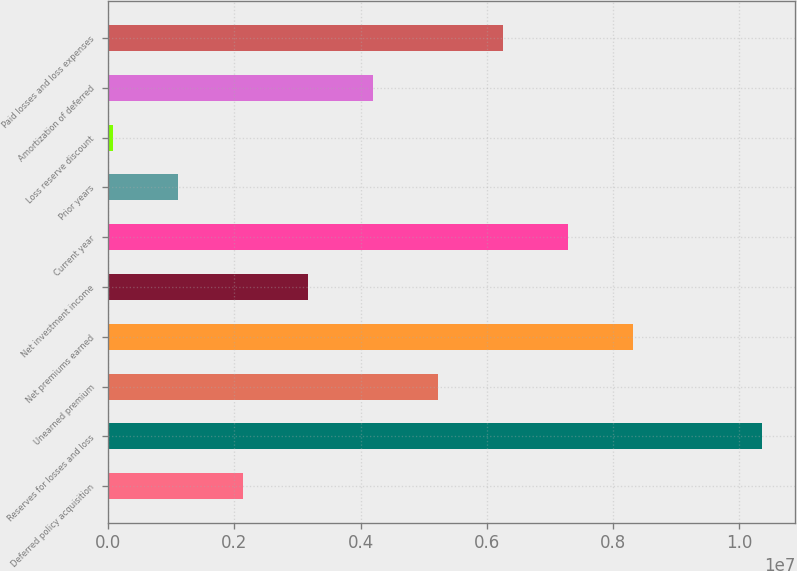<chart> <loc_0><loc_0><loc_500><loc_500><bar_chart><fcel>Deferred policy acquisition<fcel>Reserves for losses and loss<fcel>Unearned premium<fcel>Net premiums earned<fcel>Net investment income<fcel>Current year<fcel>Prior years<fcel>Loss reserve discount<fcel>Amortization of deferred<fcel>Paid losses and loss expenses<nl><fcel>2.13034e+06<fcel>1.03697e+07<fcel>5.2201e+06<fcel>8.30986e+06<fcel>3.16026e+06<fcel>7.27994e+06<fcel>1.10043e+06<fcel>70506<fcel>4.19018e+06<fcel>6.25002e+06<nl></chart> 